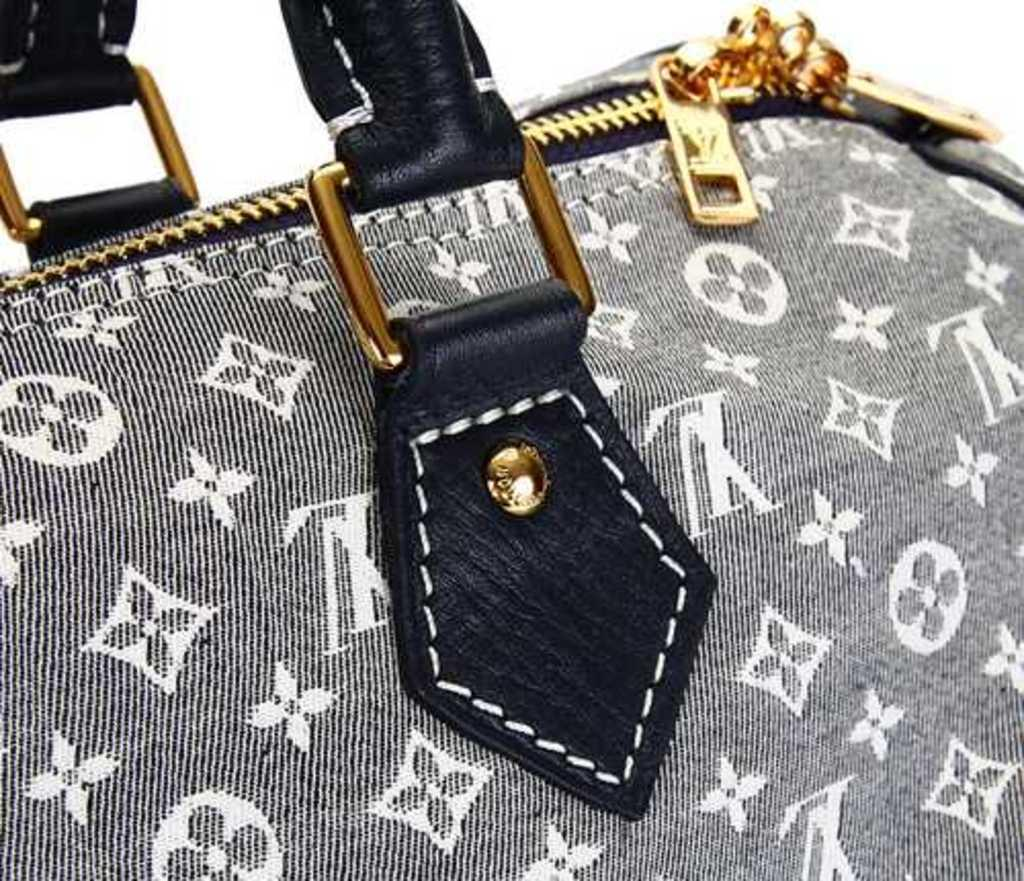What object can be seen in the image? There is a bag in the image. What color combination is the bag in? The bag is in a white and black combination. What type of view can be seen from the bag in the image? The image does not provide any information about a view, as it only shows a bag with a white and black color combination. Is there any wine visible in the image? There is no wine present in the image. Can you hear any thunder in the image? The image does not provide any auditory information, as it is a static visual representation. 